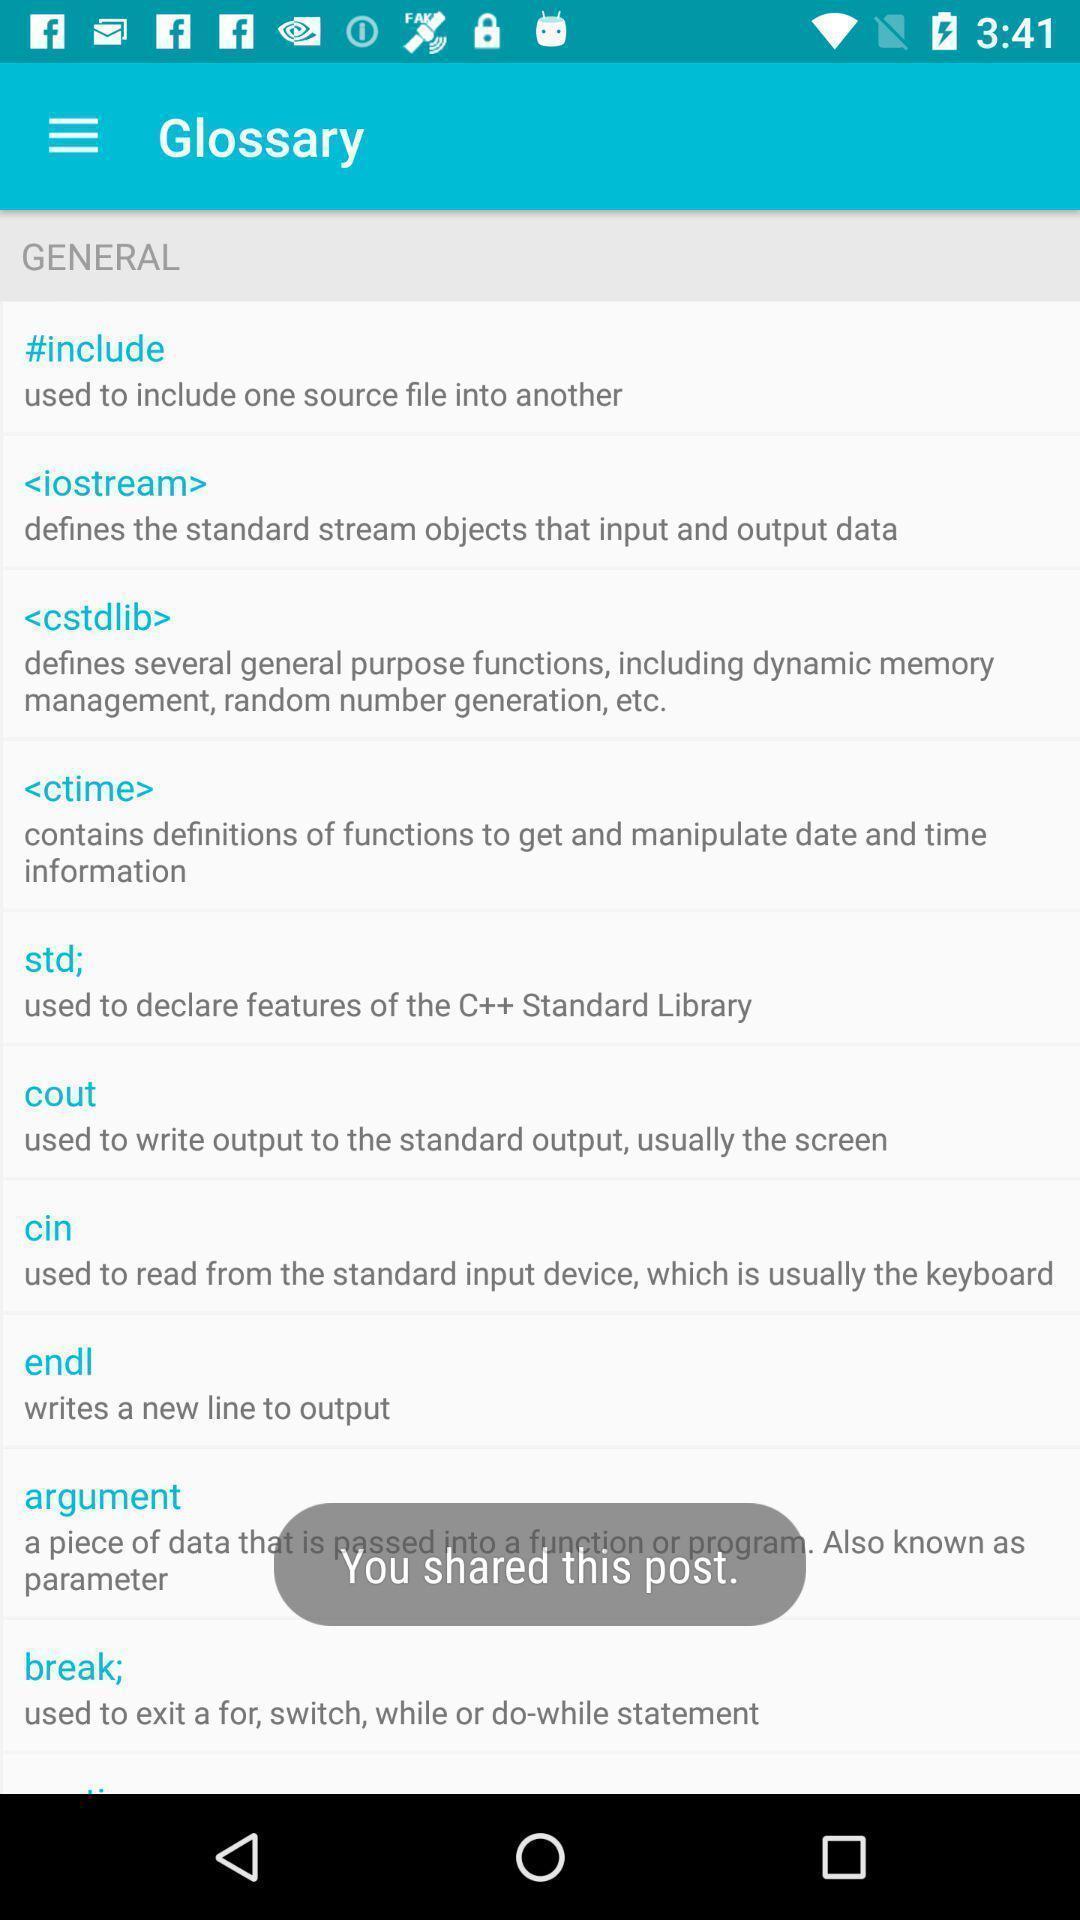Explain what's happening in this screen capture. Screen shows different glossary meanings. 